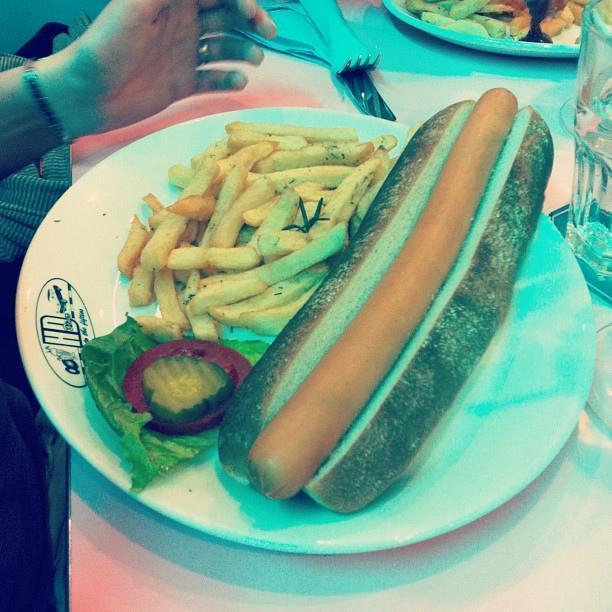Is the statement "The person is touching the hot dog." accurate regarding the image?
Answer yes or no. No. 